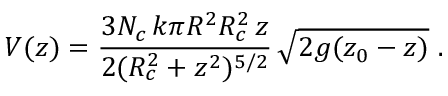Convert formula to latex. <formula><loc_0><loc_0><loc_500><loc_500>V ( z ) = \frac { 3 N _ { c } \, k \pi R ^ { 2 } R _ { c } ^ { 2 } \, z } { 2 ( R _ { c } ^ { 2 } + z ^ { 2 } ) ^ { 5 / 2 } } \, \sqrt { 2 g ( z _ { 0 } - z ) } \, .</formula> 